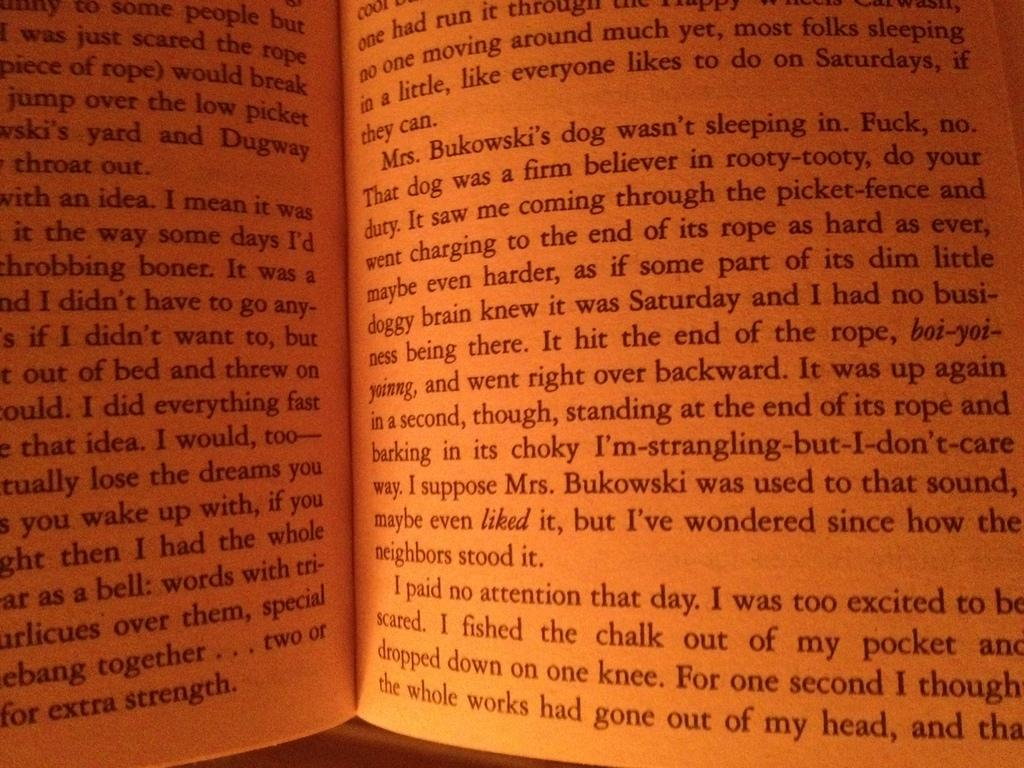Provide a one-sentence caption for the provided image. A book is opened to a page describing a character by the name of Mrs. Bukowski. 